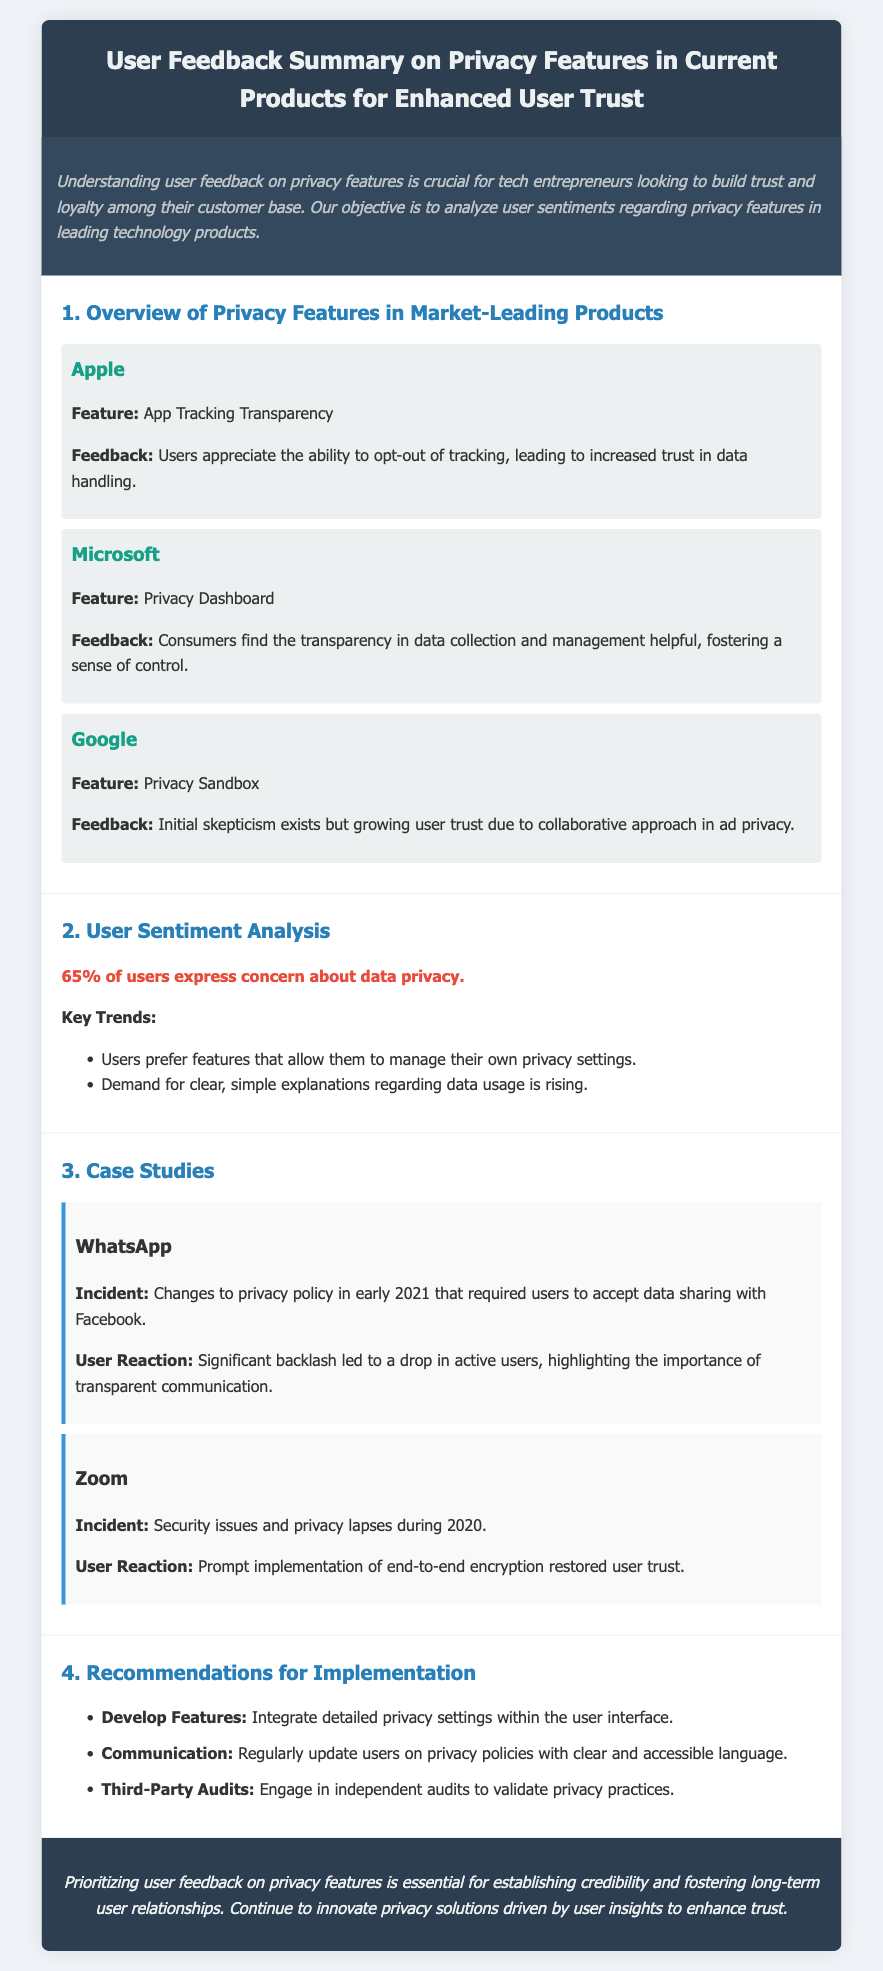what is the feedback from Apple users regarding privacy features? Users appreciate the ability to opt-out of tracking, leading to increased trust in data handling.
Answer: Increased trust what feature does Microsoft offer related to privacy? The Privacy Dashboard is a feature offered by Microsoft to enhance user privacy management.
Answer: Privacy Dashboard what percentage of users express concern about data privacy? The document states that 65% of users express concern about data privacy.
Answer: 65% which company had significant backlash due to changes in their privacy policy? The document refers to WhatsApp experiencing significant backlash due to policy changes in early 2021.
Answer: WhatsApp what is one key trend mentioned in the user sentiment analysis? Users prefer features that allow them to manage their own privacy settings.
Answer: Manage their own privacy settings which incident restored user trust for Zoom? The prompt implementation of end-to-end encryption during 2020 restored user trust in Zoom.
Answer: End-to-end encryption what is one of the recommendations made in the document? The document recommends integrating detailed privacy settings within the user interface.
Answer: Integrate detailed privacy settings who is the target audience of this privacy features feedback summary? The summary targets technology entrepreneurs looking to build trust and loyalty among their customer base.
Answer: Technology entrepreneurs 